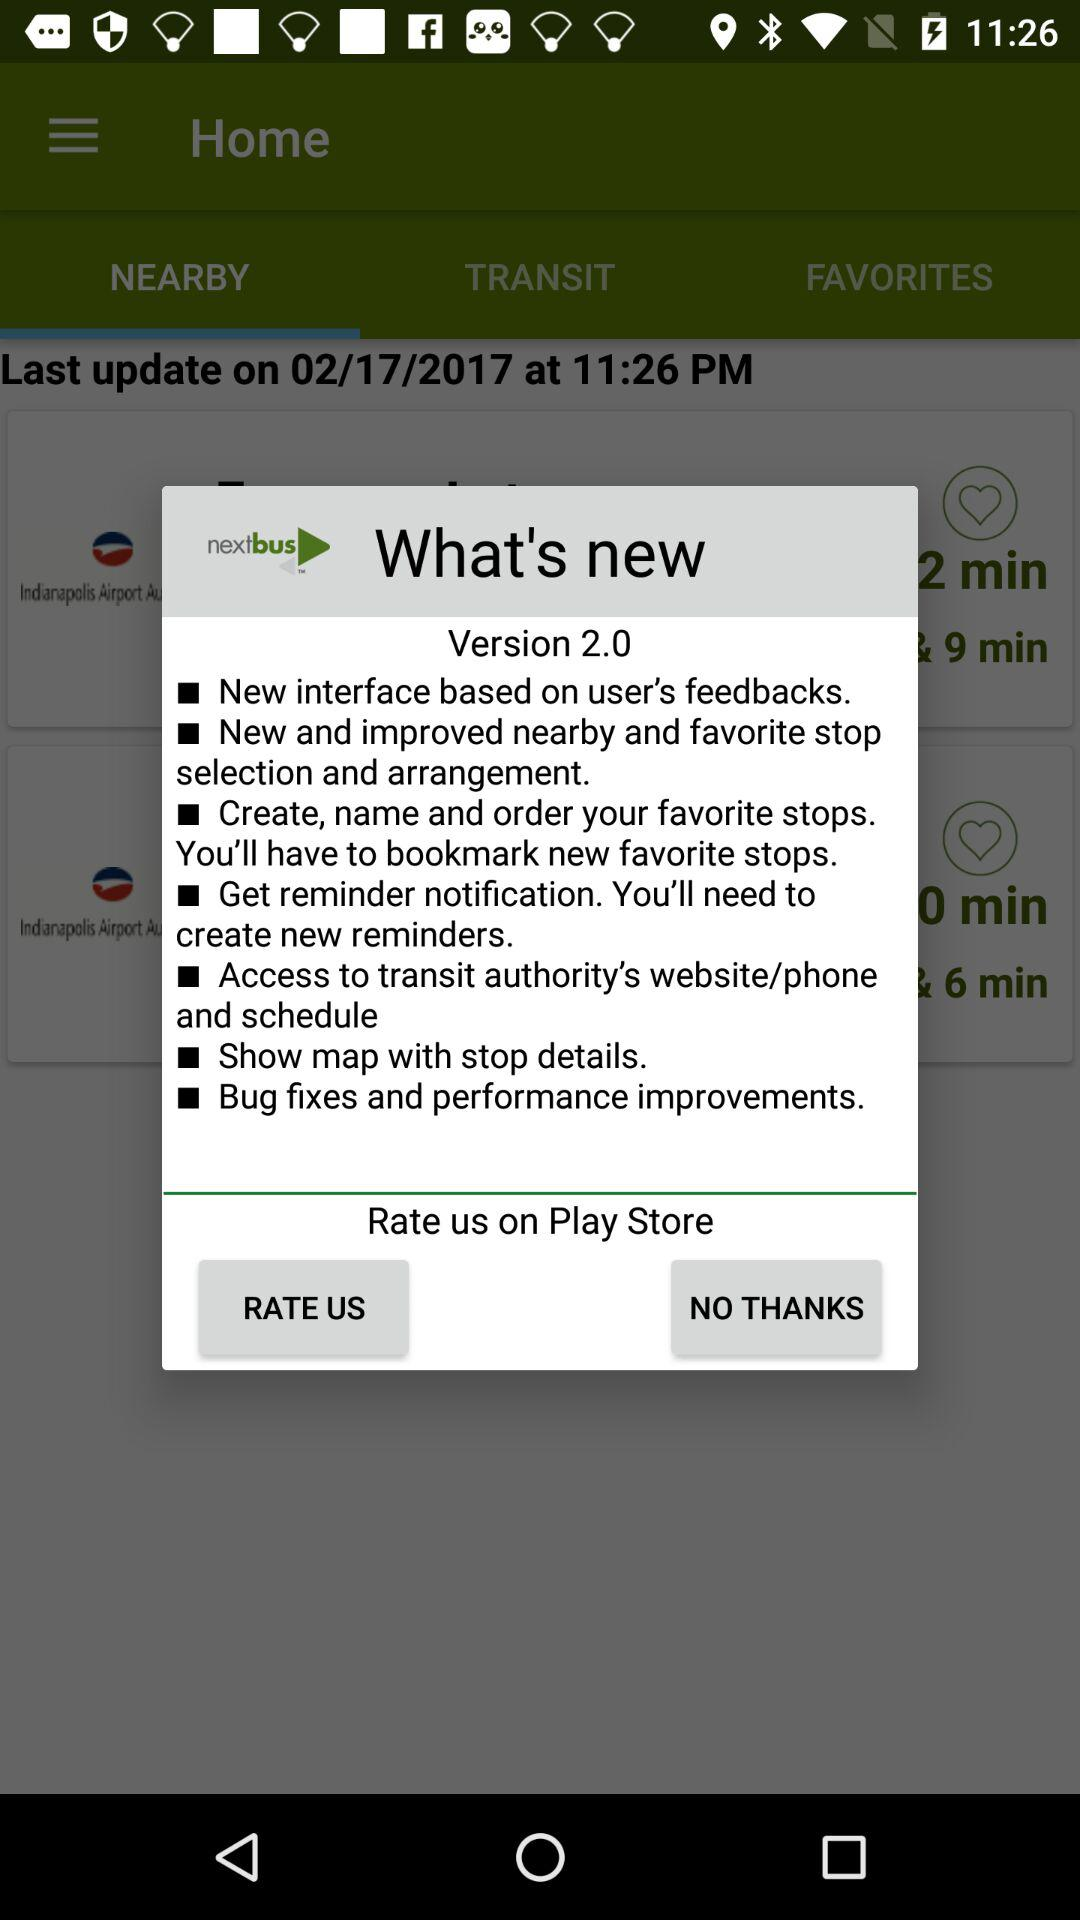What is the date of last update? The date of last update is February 17, 2017. 